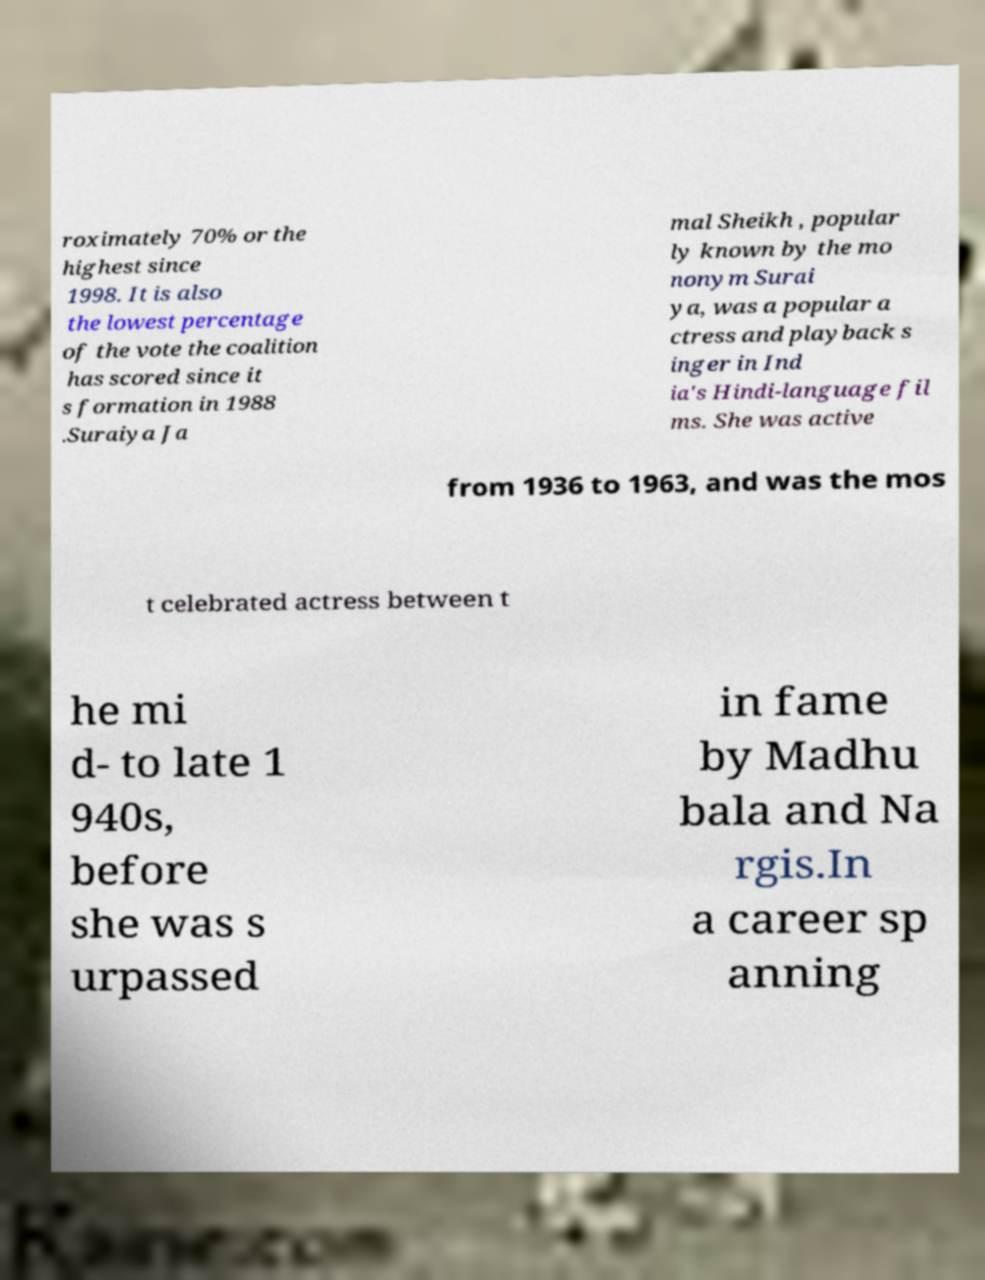What messages or text are displayed in this image? I need them in a readable, typed format. roximately 70% or the highest since 1998. It is also the lowest percentage of the vote the coalition has scored since it s formation in 1988 .Suraiya Ja mal Sheikh , popular ly known by the mo nonym Surai ya, was a popular a ctress and playback s inger in Ind ia's Hindi-language fil ms. She was active from 1936 to 1963, and was the mos t celebrated actress between t he mi d- to late 1 940s, before she was s urpassed in fame by Madhu bala and Na rgis.In a career sp anning 